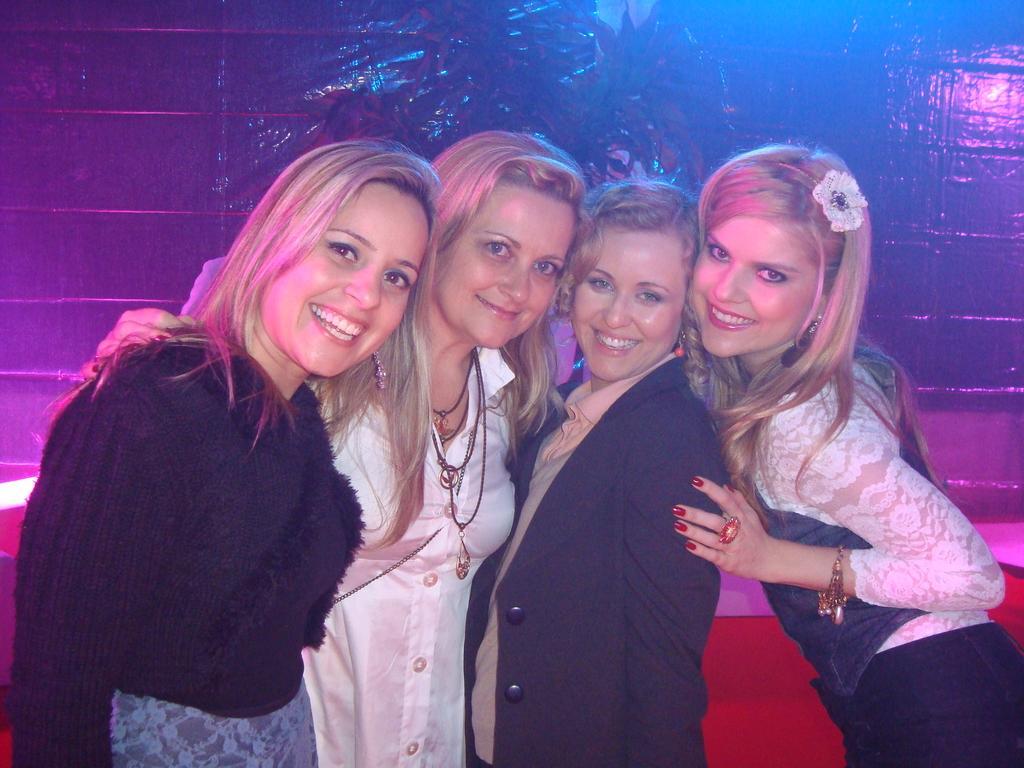How would you summarize this image in a sentence or two? There are four women standing and smiling. This looks like a couch, which is red in color. I think this is the wall. 